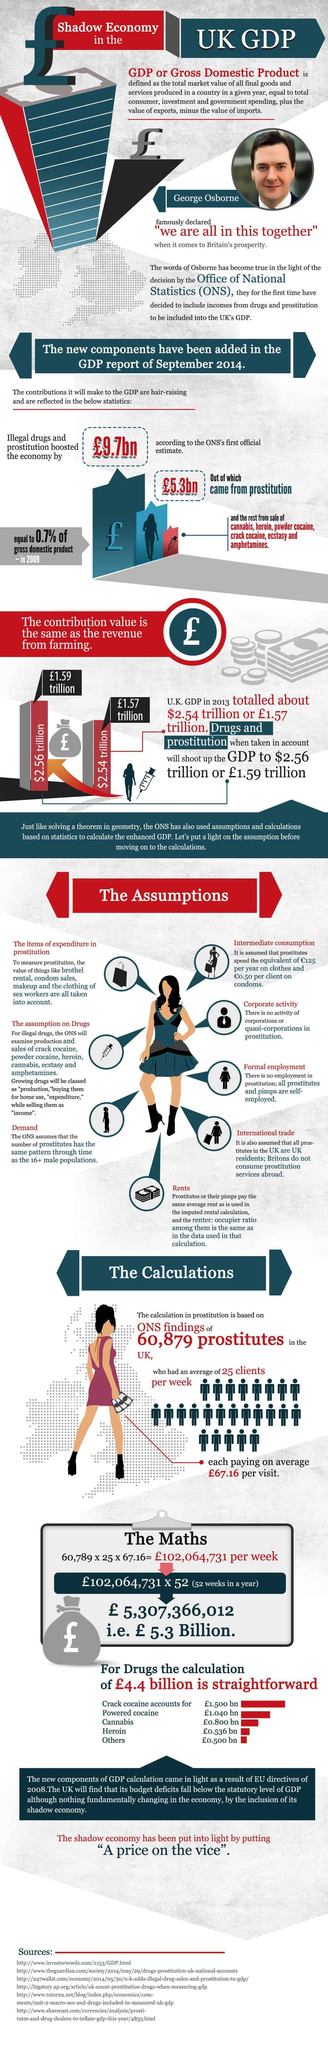How many sources are listed at the bottom?
Answer the question with a short phrase. 6 